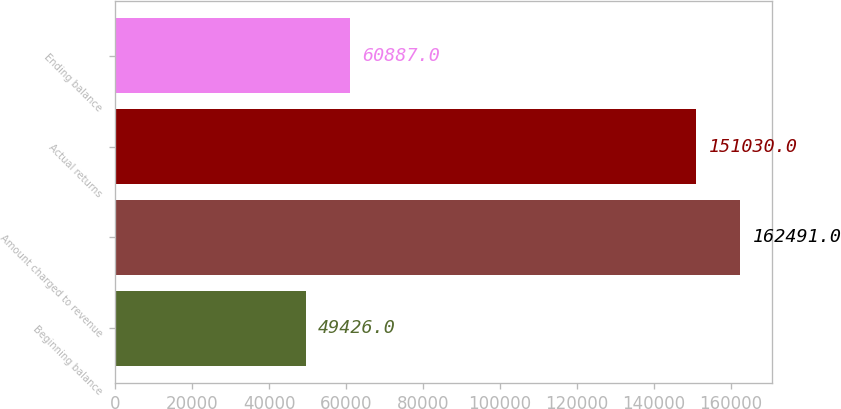Convert chart to OTSL. <chart><loc_0><loc_0><loc_500><loc_500><bar_chart><fcel>Beginning balance<fcel>Amount charged to revenue<fcel>Actual returns<fcel>Ending balance<nl><fcel>49426<fcel>162491<fcel>151030<fcel>60887<nl></chart> 